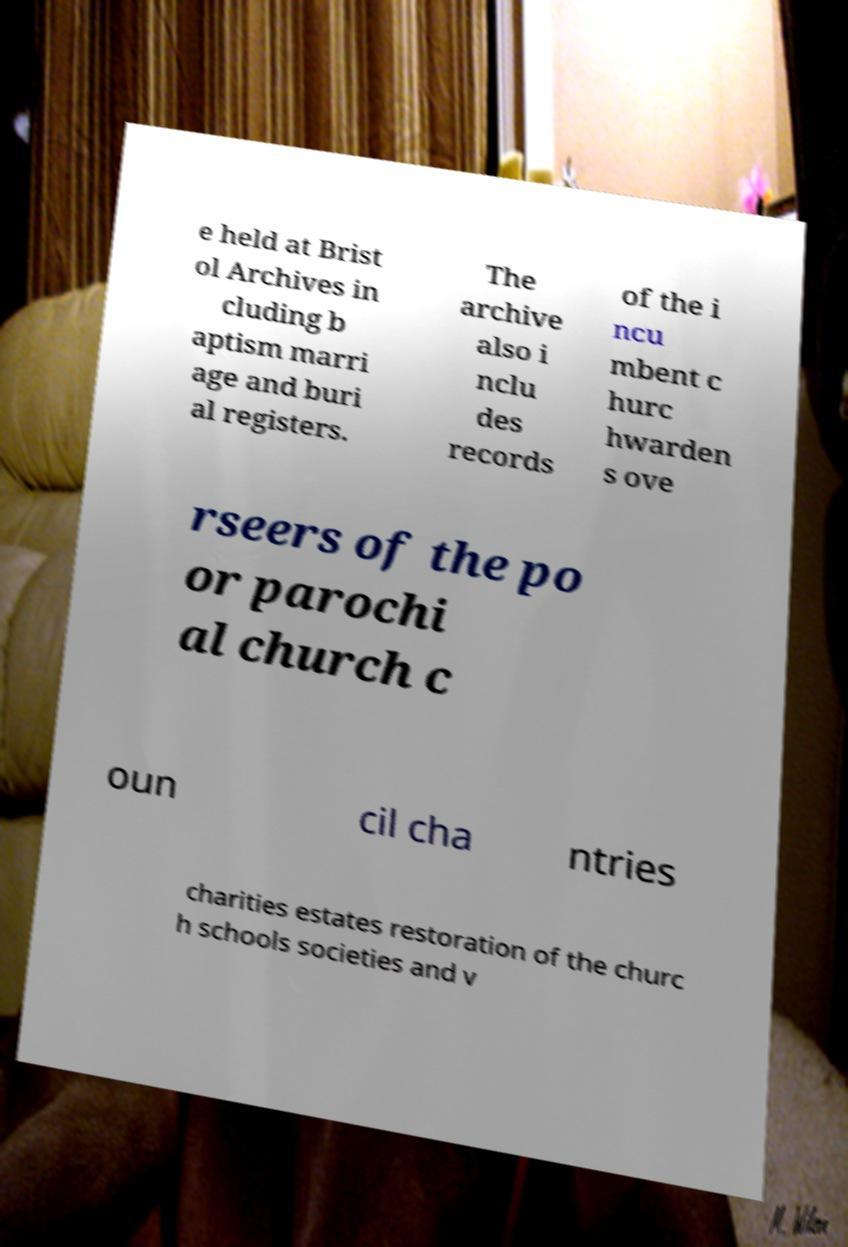Could you assist in decoding the text presented in this image and type it out clearly? e held at Brist ol Archives in cluding b aptism marri age and buri al registers. The archive also i nclu des records of the i ncu mbent c hurc hwarden s ove rseers of the po or parochi al church c oun cil cha ntries charities estates restoration of the churc h schools societies and v 